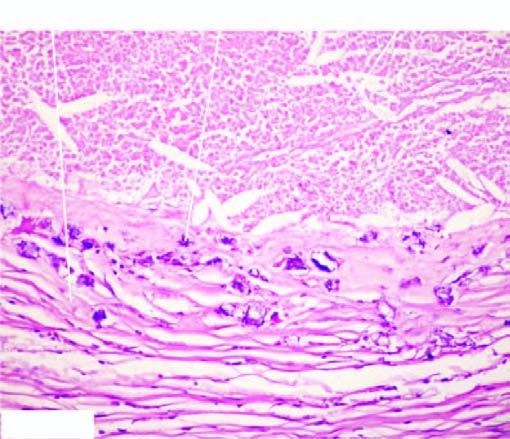does microscopy show healed granulomas?
Answer the question using a single word or phrase. No 